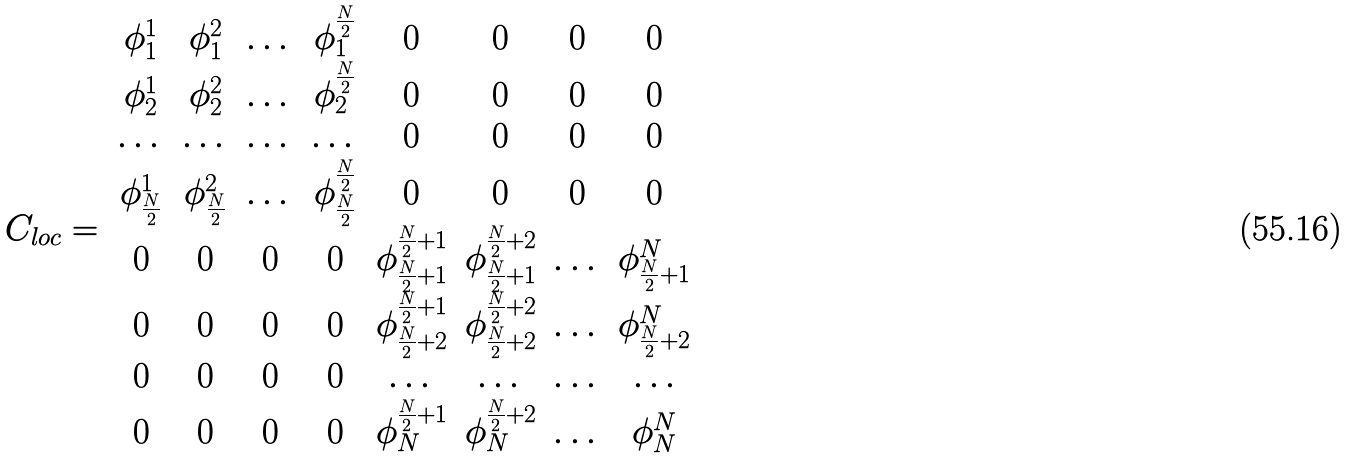Convert formula to latex. <formula><loc_0><loc_0><loc_500><loc_500>C _ { l o c } = \begin{array} { c c c c c c c c } \phi ^ { 1 } _ { 1 } & \phi ^ { 2 } _ { 1 } & \dots & \phi ^ { \frac { N } { 2 } } _ { 1 } & 0 & 0 & 0 & 0 \\ \phi ^ { 1 } _ { 2 } & \phi ^ { 2 } _ { 2 } & \dots & \phi ^ { \frac { N } { 2 } } _ { 2 } & 0 & 0 & 0 & 0 \\ \dots & \dots & \dots & \dots & 0 & 0 & 0 & 0 \\ \phi ^ { 1 } _ { \frac { N } { 2 } } & \phi ^ { 2 } _ { \frac { N } { 2 } } & \dots & \phi ^ { \frac { N } { 2 } } _ { \frac { N } { 2 } } & 0 & 0 & 0 & 0 \\ 0 & 0 & 0 & 0 & \phi ^ { \frac { N } { 2 } + 1 } _ { \frac { N } { 2 } + 1 } & \phi ^ { \frac { N } { 2 } + 2 } _ { \frac { N } { 2 } + 1 } & \dots & \phi ^ { N } _ { \frac { N } { 2 } + 1 } \\ 0 & 0 & 0 & 0 & \phi ^ { \frac { N } { 2 } + 1 } _ { \frac { N } { 2 } + 2 } & \phi ^ { \frac { N } { 2 } + 2 } _ { \frac { N } { 2 } + 2 } & \dots & \phi ^ { N } _ { \frac { N } { 2 } + 2 } \\ 0 & 0 & 0 & 0 & \dots & \dots & \dots & \dots \\ 0 & 0 & 0 & 0 & \phi ^ { \frac { N } { 2 } + 1 } _ { N } & \phi ^ { \frac { N } { 2 } + 2 } _ { N } & \dots & \phi ^ { N } _ { N } \end{array}</formula> 